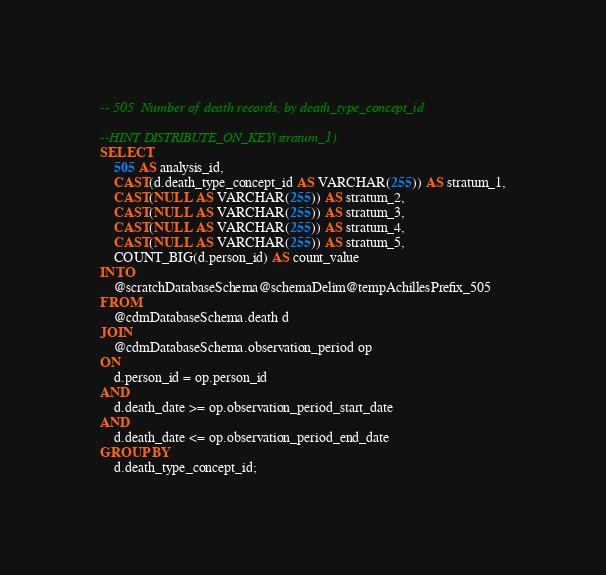<code> <loc_0><loc_0><loc_500><loc_500><_SQL_>-- 505	Number of death records, by death_type_concept_id

--HINT DISTRIBUTE_ON_KEY(stratum_1)
SELECT 
	505 AS analysis_id,
	CAST(d.death_type_concept_id AS VARCHAR(255)) AS stratum_1,
	CAST(NULL AS VARCHAR(255)) AS stratum_2,
	CAST(NULL AS VARCHAR(255)) AS stratum_3,
	CAST(NULL AS VARCHAR(255)) AS stratum_4,
	CAST(NULL AS VARCHAR(255)) AS stratum_5,
	COUNT_BIG(d.person_id) AS count_value
INTO 
	@scratchDatabaseSchema@schemaDelim@tempAchillesPrefix_505
FROM 
	@cdmDatabaseSchema.death d
JOIN 
	@cdmDatabaseSchema.observation_period op 
ON 
	d.person_id = op.person_id
AND 
	d.death_date >= op.observation_period_start_date
AND 
	d.death_date <= op.observation_period_end_date	
GROUP BY 
	d.death_type_concept_id;
</code> 